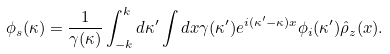Convert formula to latex. <formula><loc_0><loc_0><loc_500><loc_500>\phi _ { s } ( \kappa ) = \frac { 1 } { \gamma ( \kappa ) } \int ^ { k } _ { - k } d \kappa ^ { \prime } \int d x \gamma ( \kappa ^ { \prime } ) e ^ { i ( \kappa ^ { \prime } - \kappa ) x } \phi _ { i } ( \kappa ^ { \prime } ) \hat { \rho } _ { z } ( x ) .</formula> 